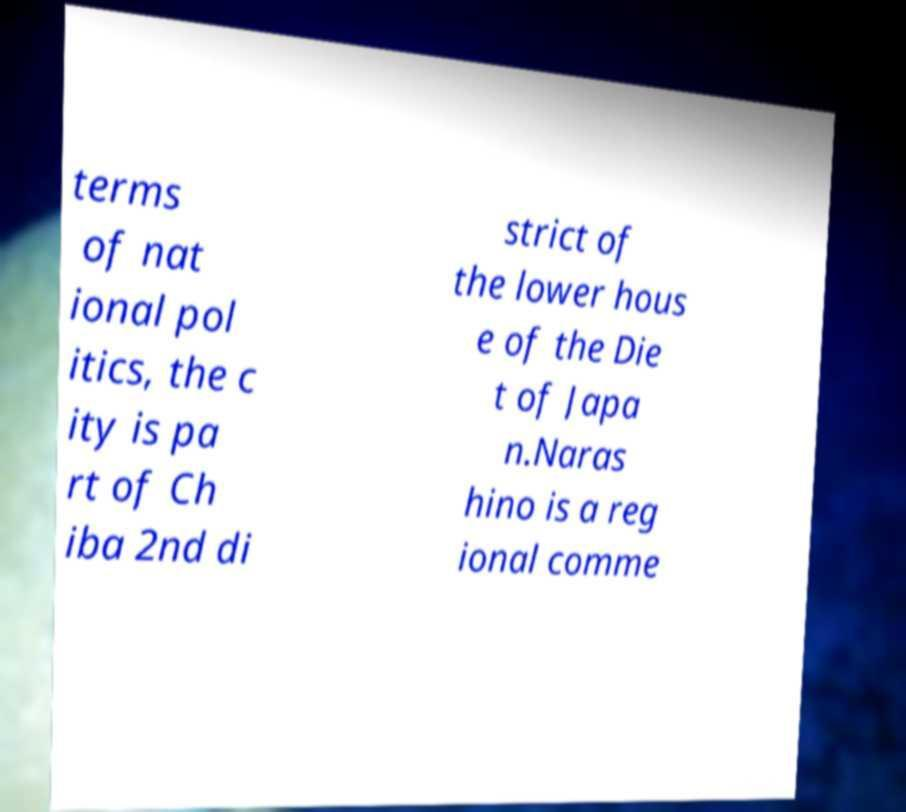I need the written content from this picture converted into text. Can you do that? terms of nat ional pol itics, the c ity is pa rt of Ch iba 2nd di strict of the lower hous e of the Die t of Japa n.Naras hino is a reg ional comme 